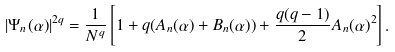<formula> <loc_0><loc_0><loc_500><loc_500>| \Psi _ { n } ( \alpha ) | ^ { 2 q } = \frac { 1 } { N ^ { q } } \left [ 1 + q ( A _ { n } ( \alpha ) + B _ { n } ( \alpha ) ) + \frac { q ( q - 1 ) } { 2 } A _ { n } ( \alpha ) ^ { 2 } \right ] .</formula> 